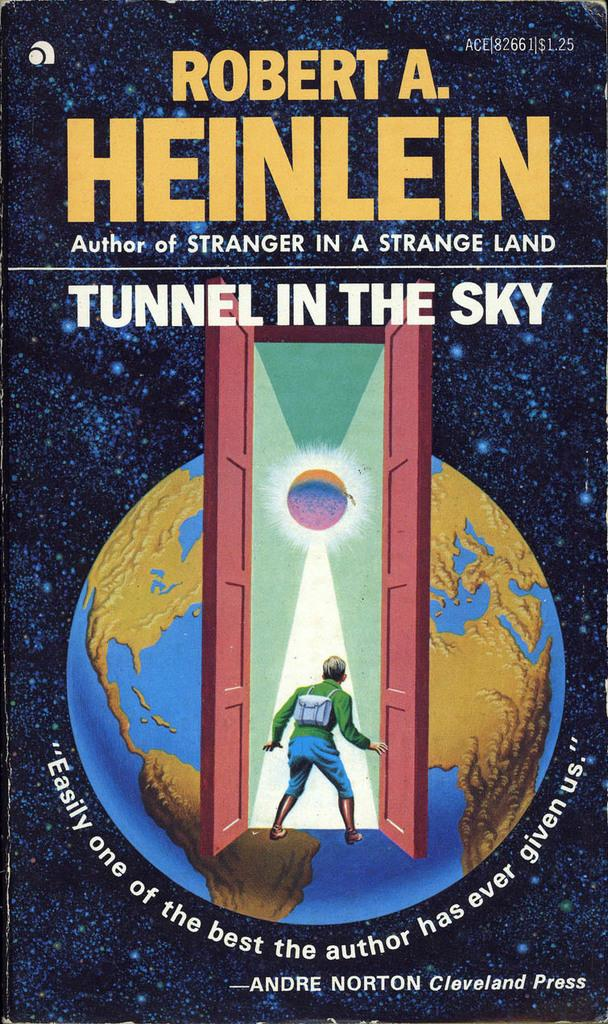Provide a one-sentence caption for the provided image. A book cover with a globe and a title of Tunnel in The Sky. 